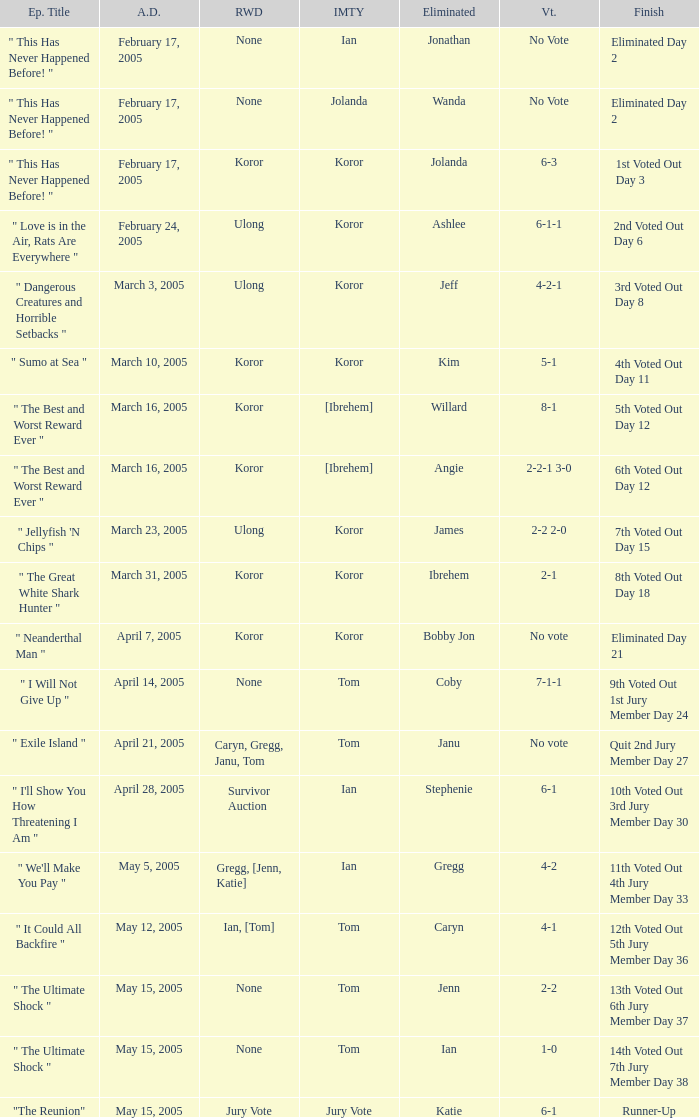What is the name of the episode in which Jenn is eliminated? " The Ultimate Shock ". 